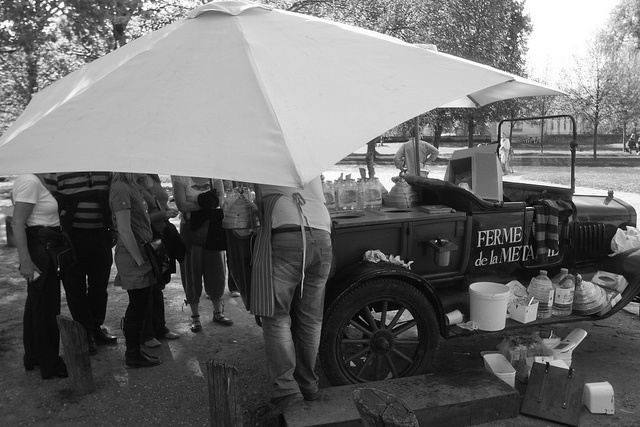Describe the objects in this image and their specific colors. I can see umbrella in gray, darkgray, lightgray, and black tones, truck in gray, black, darkgray, and lightgray tones, people in gray, black, darkgray, and lightgray tones, people in gray, black, darkgray, and lightgray tones, and people in gray, black, darkgray, and lightgray tones in this image. 